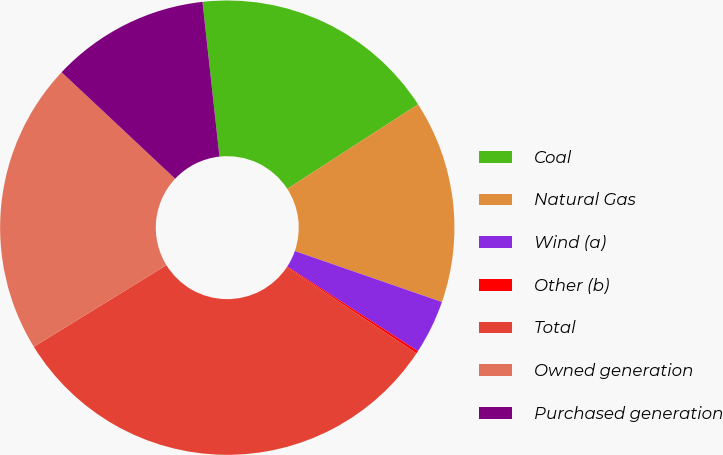<chart> <loc_0><loc_0><loc_500><loc_500><pie_chart><fcel>Coal<fcel>Natural Gas<fcel>Wind (a)<fcel>Other (b)<fcel>Total<fcel>Owned generation<fcel>Purchased generation<nl><fcel>17.61%<fcel>14.44%<fcel>3.84%<fcel>0.18%<fcel>31.89%<fcel>20.78%<fcel>11.27%<nl></chart> 